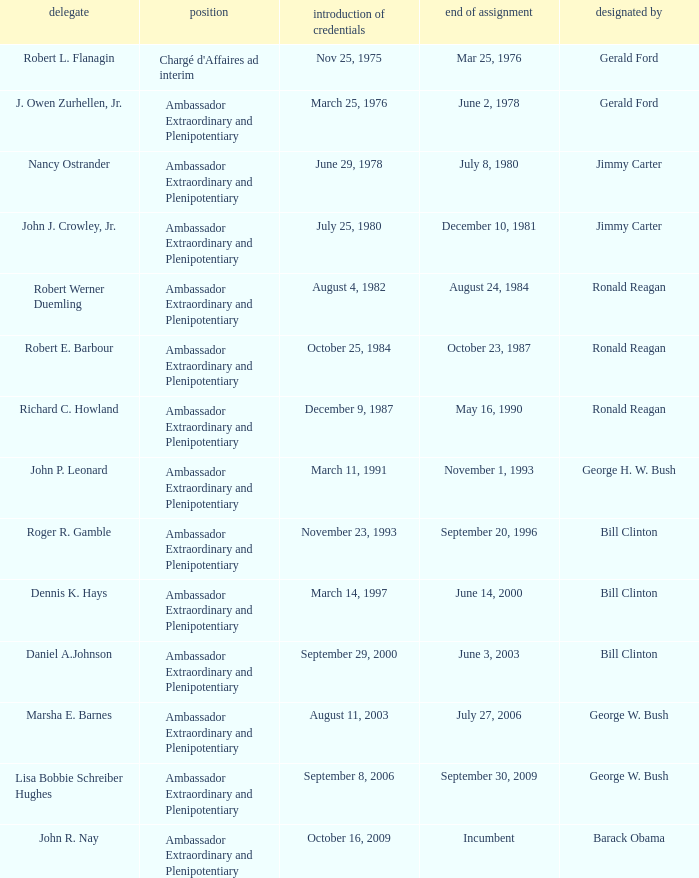What was the Termination of Mission date for the ambassador who was appointed by Barack Obama? Incumbent. Could you parse the entire table? {'header': ['delegate', 'position', 'introduction of credentials', 'end of assignment', 'designated by'], 'rows': [['Robert L. Flanagin', "Chargé d'Affaires ad interim", 'Nov 25, 1975', 'Mar 25, 1976', 'Gerald Ford'], ['J. Owen Zurhellen, Jr.', 'Ambassador Extraordinary and Plenipotentiary', 'March 25, 1976', 'June 2, 1978', 'Gerald Ford'], ['Nancy Ostrander', 'Ambassador Extraordinary and Plenipotentiary', 'June 29, 1978', 'July 8, 1980', 'Jimmy Carter'], ['John J. Crowley, Jr.', 'Ambassador Extraordinary and Plenipotentiary', 'July 25, 1980', 'December 10, 1981', 'Jimmy Carter'], ['Robert Werner Duemling', 'Ambassador Extraordinary and Plenipotentiary', 'August 4, 1982', 'August 24, 1984', 'Ronald Reagan'], ['Robert E. Barbour', 'Ambassador Extraordinary and Plenipotentiary', 'October 25, 1984', 'October 23, 1987', 'Ronald Reagan'], ['Richard C. Howland', 'Ambassador Extraordinary and Plenipotentiary', 'December 9, 1987', 'May 16, 1990', 'Ronald Reagan'], ['John P. Leonard', 'Ambassador Extraordinary and Plenipotentiary', 'March 11, 1991', 'November 1, 1993', 'George H. W. Bush'], ['Roger R. Gamble', 'Ambassador Extraordinary and Plenipotentiary', 'November 23, 1993', 'September 20, 1996', 'Bill Clinton'], ['Dennis K. Hays', 'Ambassador Extraordinary and Plenipotentiary', 'March 14, 1997', 'June 14, 2000', 'Bill Clinton'], ['Daniel A.Johnson', 'Ambassador Extraordinary and Plenipotentiary', 'September 29, 2000', 'June 3, 2003', 'Bill Clinton'], ['Marsha E. Barnes', 'Ambassador Extraordinary and Plenipotentiary', 'August 11, 2003', 'July 27, 2006', 'George W. Bush'], ['Lisa Bobbie Schreiber Hughes', 'Ambassador Extraordinary and Plenipotentiary', 'September 8, 2006', 'September 30, 2009', 'George W. Bush'], ['John R. Nay', 'Ambassador Extraordinary and Plenipotentiary', 'October 16, 2009', 'Incumbent', 'Barack Obama']]} 